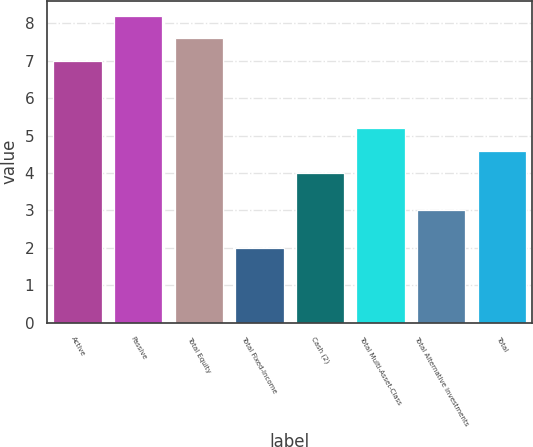<chart> <loc_0><loc_0><loc_500><loc_500><bar_chart><fcel>Active<fcel>Passive<fcel>Total Equity<fcel>Total Fixed-Income<fcel>Cash (2)<fcel>Total Multi-Asset-Class<fcel>Total Alternative Investments<fcel>Total<nl><fcel>7<fcel>8.2<fcel>7.6<fcel>2<fcel>4<fcel>5.2<fcel>3<fcel>4.6<nl></chart> 